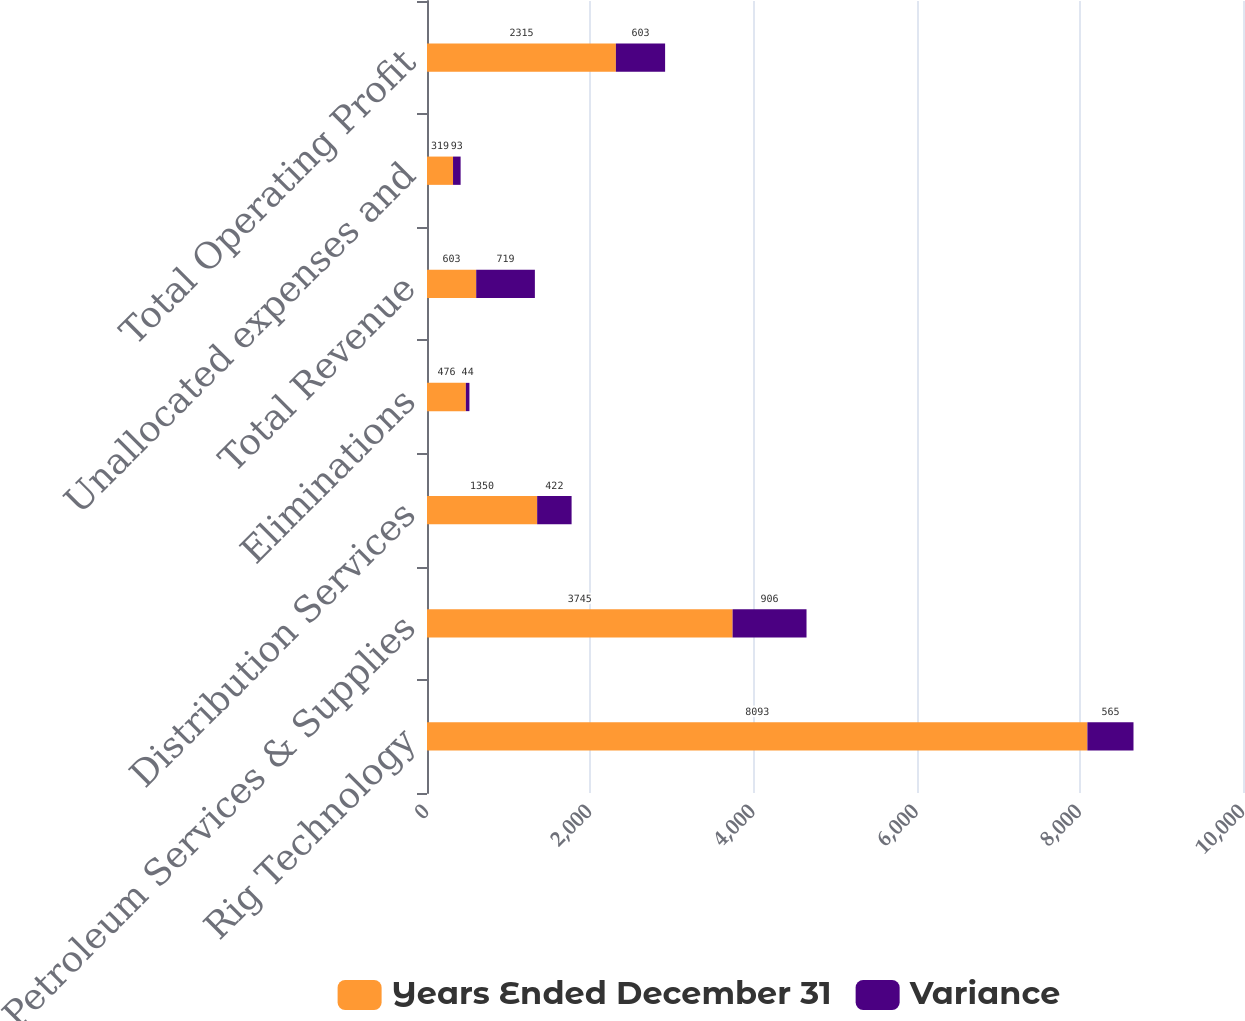<chart> <loc_0><loc_0><loc_500><loc_500><stacked_bar_chart><ecel><fcel>Rig Technology<fcel>Petroleum Services & Supplies<fcel>Distribution Services<fcel>Eliminations<fcel>Total Revenue<fcel>Unallocated expenses and<fcel>Total Operating Profit<nl><fcel>Years Ended December 31<fcel>8093<fcel>3745<fcel>1350<fcel>476<fcel>603<fcel>319<fcel>2315<nl><fcel>Variance<fcel>565<fcel>906<fcel>422<fcel>44<fcel>719<fcel>93<fcel>603<nl></chart> 